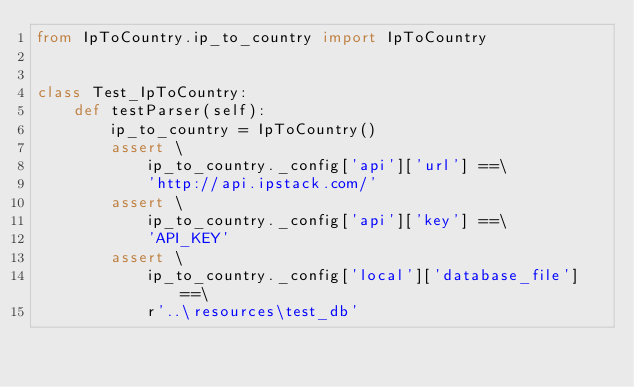<code> <loc_0><loc_0><loc_500><loc_500><_Python_>from IpToCountry.ip_to_country import IpToCountry


class Test_IpToCountry:
    def testParser(self):
        ip_to_country = IpToCountry()
        assert \
            ip_to_country._config['api']['url'] ==\
            'http://api.ipstack.com/'
        assert \
            ip_to_country._config['api']['key'] ==\
            'API_KEY'
        assert \
            ip_to_country._config['local']['database_file'] ==\
            r'..\resources\test_db'
</code> 